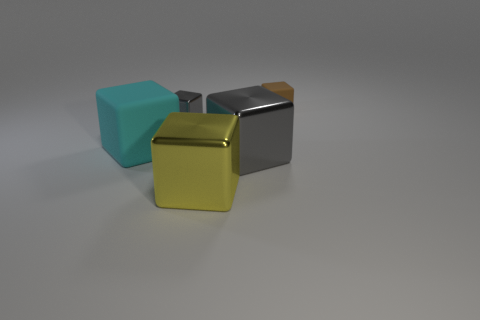Subtract 2 blocks. How many blocks are left? 3 Subtract all purple blocks. Subtract all red spheres. How many blocks are left? 5 Add 1 big gray balls. How many objects exist? 6 Add 5 big gray metallic things. How many big gray metallic things exist? 6 Subtract 1 brown cubes. How many objects are left? 4 Subtract all large cyan things. Subtract all big shiny cubes. How many objects are left? 2 Add 5 brown matte objects. How many brown matte objects are left? 6 